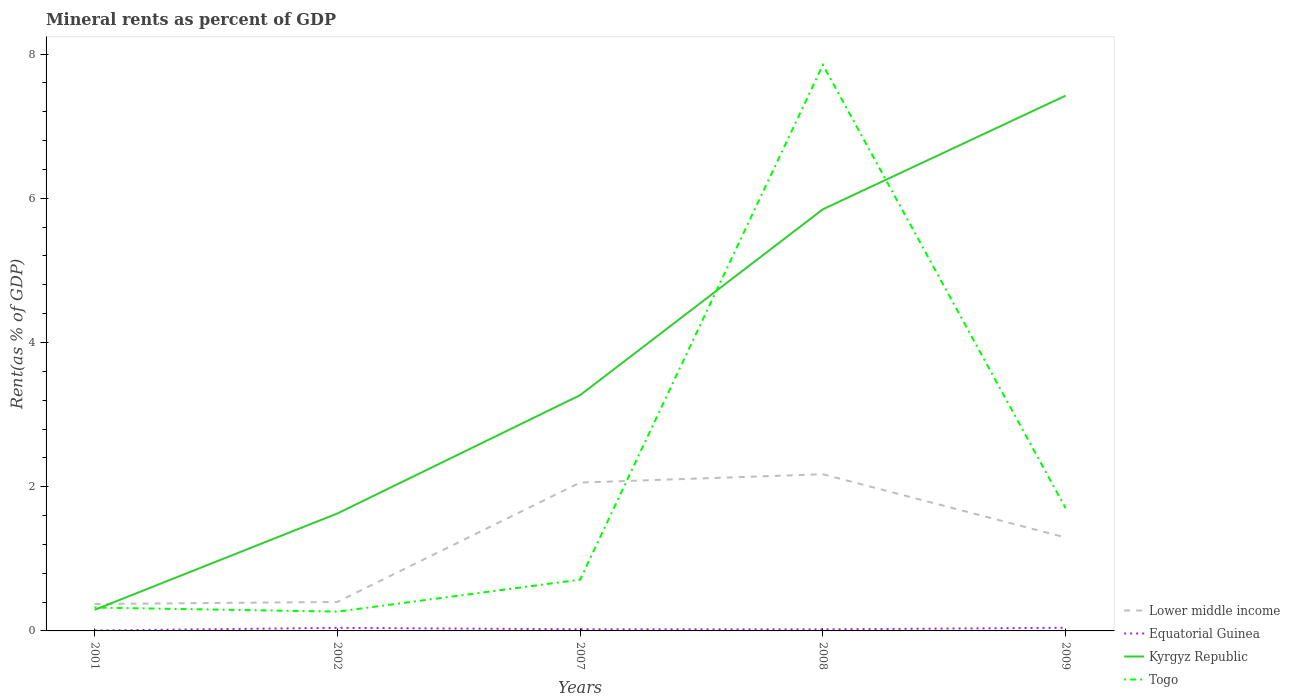Across all years, what is the maximum mineral rent in Togo?
Give a very brief answer. 0.27. What is the total mineral rent in Kyrgyz Republic in the graph?
Provide a short and direct response. -5.56. What is the difference between the highest and the second highest mineral rent in Togo?
Your answer should be very brief. 7.58. How many lines are there?
Your response must be concise. 4. Does the graph contain grids?
Make the answer very short. No. How many legend labels are there?
Your response must be concise. 4. What is the title of the graph?
Your answer should be compact. Mineral rents as percent of GDP. Does "India" appear as one of the legend labels in the graph?
Keep it short and to the point. No. What is the label or title of the X-axis?
Make the answer very short. Years. What is the label or title of the Y-axis?
Your answer should be compact. Rent(as % of GDP). What is the Rent(as % of GDP) of Lower middle income in 2001?
Provide a succinct answer. 0.37. What is the Rent(as % of GDP) in Equatorial Guinea in 2001?
Your answer should be compact. 0.01. What is the Rent(as % of GDP) of Kyrgyz Republic in 2001?
Keep it short and to the point. 0.29. What is the Rent(as % of GDP) of Togo in 2001?
Your answer should be compact. 0.32. What is the Rent(as % of GDP) in Lower middle income in 2002?
Keep it short and to the point. 0.4. What is the Rent(as % of GDP) in Equatorial Guinea in 2002?
Keep it short and to the point. 0.04. What is the Rent(as % of GDP) in Kyrgyz Republic in 2002?
Your response must be concise. 1.63. What is the Rent(as % of GDP) of Togo in 2002?
Your response must be concise. 0.27. What is the Rent(as % of GDP) in Lower middle income in 2007?
Your response must be concise. 2.06. What is the Rent(as % of GDP) in Equatorial Guinea in 2007?
Keep it short and to the point. 0.02. What is the Rent(as % of GDP) of Kyrgyz Republic in 2007?
Keep it short and to the point. 3.27. What is the Rent(as % of GDP) in Togo in 2007?
Provide a short and direct response. 0.71. What is the Rent(as % of GDP) in Lower middle income in 2008?
Offer a very short reply. 2.17. What is the Rent(as % of GDP) of Equatorial Guinea in 2008?
Your answer should be compact. 0.02. What is the Rent(as % of GDP) of Kyrgyz Republic in 2008?
Make the answer very short. 5.85. What is the Rent(as % of GDP) of Togo in 2008?
Offer a terse response. 7.85. What is the Rent(as % of GDP) of Lower middle income in 2009?
Make the answer very short. 1.3. What is the Rent(as % of GDP) in Equatorial Guinea in 2009?
Offer a very short reply. 0.04. What is the Rent(as % of GDP) of Kyrgyz Republic in 2009?
Provide a succinct answer. 7.42. What is the Rent(as % of GDP) in Togo in 2009?
Provide a succinct answer. 1.7. Across all years, what is the maximum Rent(as % of GDP) of Lower middle income?
Ensure brevity in your answer.  2.17. Across all years, what is the maximum Rent(as % of GDP) in Equatorial Guinea?
Give a very brief answer. 0.04. Across all years, what is the maximum Rent(as % of GDP) in Kyrgyz Republic?
Your answer should be compact. 7.42. Across all years, what is the maximum Rent(as % of GDP) of Togo?
Your answer should be compact. 7.85. Across all years, what is the minimum Rent(as % of GDP) of Lower middle income?
Provide a succinct answer. 0.37. Across all years, what is the minimum Rent(as % of GDP) in Equatorial Guinea?
Your answer should be very brief. 0.01. Across all years, what is the minimum Rent(as % of GDP) of Kyrgyz Republic?
Give a very brief answer. 0.29. Across all years, what is the minimum Rent(as % of GDP) of Togo?
Provide a succinct answer. 0.27. What is the total Rent(as % of GDP) in Lower middle income in the graph?
Provide a short and direct response. 6.3. What is the total Rent(as % of GDP) of Equatorial Guinea in the graph?
Provide a short and direct response. 0.14. What is the total Rent(as % of GDP) in Kyrgyz Republic in the graph?
Provide a succinct answer. 18.46. What is the total Rent(as % of GDP) of Togo in the graph?
Your answer should be very brief. 10.85. What is the difference between the Rent(as % of GDP) in Lower middle income in 2001 and that in 2002?
Keep it short and to the point. -0.03. What is the difference between the Rent(as % of GDP) of Equatorial Guinea in 2001 and that in 2002?
Your answer should be very brief. -0.04. What is the difference between the Rent(as % of GDP) in Kyrgyz Republic in 2001 and that in 2002?
Your response must be concise. -1.34. What is the difference between the Rent(as % of GDP) in Togo in 2001 and that in 2002?
Offer a terse response. 0.06. What is the difference between the Rent(as % of GDP) of Lower middle income in 2001 and that in 2007?
Keep it short and to the point. -1.68. What is the difference between the Rent(as % of GDP) of Equatorial Guinea in 2001 and that in 2007?
Offer a very short reply. -0.02. What is the difference between the Rent(as % of GDP) of Kyrgyz Republic in 2001 and that in 2007?
Give a very brief answer. -2.98. What is the difference between the Rent(as % of GDP) of Togo in 2001 and that in 2007?
Ensure brevity in your answer.  -0.39. What is the difference between the Rent(as % of GDP) of Lower middle income in 2001 and that in 2008?
Keep it short and to the point. -1.8. What is the difference between the Rent(as % of GDP) of Equatorial Guinea in 2001 and that in 2008?
Your answer should be compact. -0.02. What is the difference between the Rent(as % of GDP) of Kyrgyz Republic in 2001 and that in 2008?
Offer a very short reply. -5.56. What is the difference between the Rent(as % of GDP) in Togo in 2001 and that in 2008?
Ensure brevity in your answer.  -7.53. What is the difference between the Rent(as % of GDP) of Lower middle income in 2001 and that in 2009?
Provide a succinct answer. -0.92. What is the difference between the Rent(as % of GDP) in Equatorial Guinea in 2001 and that in 2009?
Make the answer very short. -0.04. What is the difference between the Rent(as % of GDP) of Kyrgyz Republic in 2001 and that in 2009?
Your answer should be compact. -7.13. What is the difference between the Rent(as % of GDP) of Togo in 2001 and that in 2009?
Give a very brief answer. -1.38. What is the difference between the Rent(as % of GDP) in Lower middle income in 2002 and that in 2007?
Give a very brief answer. -1.66. What is the difference between the Rent(as % of GDP) of Equatorial Guinea in 2002 and that in 2007?
Give a very brief answer. 0.02. What is the difference between the Rent(as % of GDP) of Kyrgyz Republic in 2002 and that in 2007?
Your answer should be compact. -1.64. What is the difference between the Rent(as % of GDP) in Togo in 2002 and that in 2007?
Offer a very short reply. -0.44. What is the difference between the Rent(as % of GDP) of Lower middle income in 2002 and that in 2008?
Your answer should be compact. -1.77. What is the difference between the Rent(as % of GDP) in Equatorial Guinea in 2002 and that in 2008?
Offer a terse response. 0.02. What is the difference between the Rent(as % of GDP) in Kyrgyz Republic in 2002 and that in 2008?
Your answer should be compact. -4.22. What is the difference between the Rent(as % of GDP) in Togo in 2002 and that in 2008?
Offer a very short reply. -7.58. What is the difference between the Rent(as % of GDP) of Lower middle income in 2002 and that in 2009?
Your answer should be compact. -0.89. What is the difference between the Rent(as % of GDP) of Equatorial Guinea in 2002 and that in 2009?
Make the answer very short. -0. What is the difference between the Rent(as % of GDP) of Kyrgyz Republic in 2002 and that in 2009?
Ensure brevity in your answer.  -5.79. What is the difference between the Rent(as % of GDP) in Togo in 2002 and that in 2009?
Your response must be concise. -1.43. What is the difference between the Rent(as % of GDP) in Lower middle income in 2007 and that in 2008?
Provide a succinct answer. -0.12. What is the difference between the Rent(as % of GDP) in Equatorial Guinea in 2007 and that in 2008?
Your answer should be very brief. 0. What is the difference between the Rent(as % of GDP) of Kyrgyz Republic in 2007 and that in 2008?
Your answer should be very brief. -2.58. What is the difference between the Rent(as % of GDP) in Togo in 2007 and that in 2008?
Give a very brief answer. -7.14. What is the difference between the Rent(as % of GDP) in Lower middle income in 2007 and that in 2009?
Your response must be concise. 0.76. What is the difference between the Rent(as % of GDP) of Equatorial Guinea in 2007 and that in 2009?
Ensure brevity in your answer.  -0.02. What is the difference between the Rent(as % of GDP) of Kyrgyz Republic in 2007 and that in 2009?
Your answer should be compact. -4.15. What is the difference between the Rent(as % of GDP) in Togo in 2007 and that in 2009?
Ensure brevity in your answer.  -0.99. What is the difference between the Rent(as % of GDP) of Lower middle income in 2008 and that in 2009?
Make the answer very short. 0.88. What is the difference between the Rent(as % of GDP) of Equatorial Guinea in 2008 and that in 2009?
Provide a short and direct response. -0.02. What is the difference between the Rent(as % of GDP) in Kyrgyz Republic in 2008 and that in 2009?
Make the answer very short. -1.58. What is the difference between the Rent(as % of GDP) in Togo in 2008 and that in 2009?
Your answer should be very brief. 6.15. What is the difference between the Rent(as % of GDP) in Lower middle income in 2001 and the Rent(as % of GDP) in Equatorial Guinea in 2002?
Ensure brevity in your answer.  0.33. What is the difference between the Rent(as % of GDP) in Lower middle income in 2001 and the Rent(as % of GDP) in Kyrgyz Republic in 2002?
Your answer should be very brief. -1.26. What is the difference between the Rent(as % of GDP) in Lower middle income in 2001 and the Rent(as % of GDP) in Togo in 2002?
Offer a very short reply. 0.11. What is the difference between the Rent(as % of GDP) of Equatorial Guinea in 2001 and the Rent(as % of GDP) of Kyrgyz Republic in 2002?
Your answer should be very brief. -1.62. What is the difference between the Rent(as % of GDP) in Equatorial Guinea in 2001 and the Rent(as % of GDP) in Togo in 2002?
Provide a succinct answer. -0.26. What is the difference between the Rent(as % of GDP) of Kyrgyz Republic in 2001 and the Rent(as % of GDP) of Togo in 2002?
Offer a very short reply. 0.02. What is the difference between the Rent(as % of GDP) of Lower middle income in 2001 and the Rent(as % of GDP) of Equatorial Guinea in 2007?
Ensure brevity in your answer.  0.35. What is the difference between the Rent(as % of GDP) in Lower middle income in 2001 and the Rent(as % of GDP) in Kyrgyz Republic in 2007?
Provide a short and direct response. -2.9. What is the difference between the Rent(as % of GDP) of Lower middle income in 2001 and the Rent(as % of GDP) of Togo in 2007?
Your answer should be very brief. -0.34. What is the difference between the Rent(as % of GDP) in Equatorial Guinea in 2001 and the Rent(as % of GDP) in Kyrgyz Republic in 2007?
Provide a short and direct response. -3.26. What is the difference between the Rent(as % of GDP) of Equatorial Guinea in 2001 and the Rent(as % of GDP) of Togo in 2007?
Provide a succinct answer. -0.7. What is the difference between the Rent(as % of GDP) of Kyrgyz Republic in 2001 and the Rent(as % of GDP) of Togo in 2007?
Your response must be concise. -0.42. What is the difference between the Rent(as % of GDP) in Lower middle income in 2001 and the Rent(as % of GDP) in Equatorial Guinea in 2008?
Your response must be concise. 0.35. What is the difference between the Rent(as % of GDP) of Lower middle income in 2001 and the Rent(as % of GDP) of Kyrgyz Republic in 2008?
Provide a short and direct response. -5.47. What is the difference between the Rent(as % of GDP) of Lower middle income in 2001 and the Rent(as % of GDP) of Togo in 2008?
Your answer should be very brief. -7.48. What is the difference between the Rent(as % of GDP) of Equatorial Guinea in 2001 and the Rent(as % of GDP) of Kyrgyz Republic in 2008?
Keep it short and to the point. -5.84. What is the difference between the Rent(as % of GDP) of Equatorial Guinea in 2001 and the Rent(as % of GDP) of Togo in 2008?
Give a very brief answer. -7.84. What is the difference between the Rent(as % of GDP) of Kyrgyz Republic in 2001 and the Rent(as % of GDP) of Togo in 2008?
Keep it short and to the point. -7.56. What is the difference between the Rent(as % of GDP) of Lower middle income in 2001 and the Rent(as % of GDP) of Equatorial Guinea in 2009?
Make the answer very short. 0.33. What is the difference between the Rent(as % of GDP) of Lower middle income in 2001 and the Rent(as % of GDP) of Kyrgyz Republic in 2009?
Your response must be concise. -7.05. What is the difference between the Rent(as % of GDP) in Lower middle income in 2001 and the Rent(as % of GDP) in Togo in 2009?
Keep it short and to the point. -1.33. What is the difference between the Rent(as % of GDP) of Equatorial Guinea in 2001 and the Rent(as % of GDP) of Kyrgyz Republic in 2009?
Give a very brief answer. -7.42. What is the difference between the Rent(as % of GDP) of Equatorial Guinea in 2001 and the Rent(as % of GDP) of Togo in 2009?
Your answer should be compact. -1.7. What is the difference between the Rent(as % of GDP) of Kyrgyz Republic in 2001 and the Rent(as % of GDP) of Togo in 2009?
Provide a succinct answer. -1.41. What is the difference between the Rent(as % of GDP) of Lower middle income in 2002 and the Rent(as % of GDP) of Equatorial Guinea in 2007?
Your response must be concise. 0.38. What is the difference between the Rent(as % of GDP) in Lower middle income in 2002 and the Rent(as % of GDP) in Kyrgyz Republic in 2007?
Offer a terse response. -2.87. What is the difference between the Rent(as % of GDP) of Lower middle income in 2002 and the Rent(as % of GDP) of Togo in 2007?
Give a very brief answer. -0.31. What is the difference between the Rent(as % of GDP) of Equatorial Guinea in 2002 and the Rent(as % of GDP) of Kyrgyz Republic in 2007?
Provide a succinct answer. -3.23. What is the difference between the Rent(as % of GDP) of Equatorial Guinea in 2002 and the Rent(as % of GDP) of Togo in 2007?
Your answer should be very brief. -0.67. What is the difference between the Rent(as % of GDP) of Kyrgyz Republic in 2002 and the Rent(as % of GDP) of Togo in 2007?
Ensure brevity in your answer.  0.92. What is the difference between the Rent(as % of GDP) in Lower middle income in 2002 and the Rent(as % of GDP) in Equatorial Guinea in 2008?
Offer a very short reply. 0.38. What is the difference between the Rent(as % of GDP) in Lower middle income in 2002 and the Rent(as % of GDP) in Kyrgyz Republic in 2008?
Your answer should be very brief. -5.45. What is the difference between the Rent(as % of GDP) in Lower middle income in 2002 and the Rent(as % of GDP) in Togo in 2008?
Offer a very short reply. -7.45. What is the difference between the Rent(as % of GDP) in Equatorial Guinea in 2002 and the Rent(as % of GDP) in Kyrgyz Republic in 2008?
Offer a very short reply. -5.8. What is the difference between the Rent(as % of GDP) in Equatorial Guinea in 2002 and the Rent(as % of GDP) in Togo in 2008?
Provide a succinct answer. -7.81. What is the difference between the Rent(as % of GDP) in Kyrgyz Republic in 2002 and the Rent(as % of GDP) in Togo in 2008?
Ensure brevity in your answer.  -6.22. What is the difference between the Rent(as % of GDP) of Lower middle income in 2002 and the Rent(as % of GDP) of Equatorial Guinea in 2009?
Your answer should be compact. 0.36. What is the difference between the Rent(as % of GDP) of Lower middle income in 2002 and the Rent(as % of GDP) of Kyrgyz Republic in 2009?
Your answer should be very brief. -7.02. What is the difference between the Rent(as % of GDP) of Lower middle income in 2002 and the Rent(as % of GDP) of Togo in 2009?
Make the answer very short. -1.3. What is the difference between the Rent(as % of GDP) of Equatorial Guinea in 2002 and the Rent(as % of GDP) of Kyrgyz Republic in 2009?
Provide a succinct answer. -7.38. What is the difference between the Rent(as % of GDP) of Equatorial Guinea in 2002 and the Rent(as % of GDP) of Togo in 2009?
Keep it short and to the point. -1.66. What is the difference between the Rent(as % of GDP) in Kyrgyz Republic in 2002 and the Rent(as % of GDP) in Togo in 2009?
Offer a terse response. -0.07. What is the difference between the Rent(as % of GDP) in Lower middle income in 2007 and the Rent(as % of GDP) in Equatorial Guinea in 2008?
Offer a very short reply. 2.04. What is the difference between the Rent(as % of GDP) of Lower middle income in 2007 and the Rent(as % of GDP) of Kyrgyz Republic in 2008?
Provide a short and direct response. -3.79. What is the difference between the Rent(as % of GDP) in Lower middle income in 2007 and the Rent(as % of GDP) in Togo in 2008?
Give a very brief answer. -5.79. What is the difference between the Rent(as % of GDP) in Equatorial Guinea in 2007 and the Rent(as % of GDP) in Kyrgyz Republic in 2008?
Give a very brief answer. -5.82. What is the difference between the Rent(as % of GDP) of Equatorial Guinea in 2007 and the Rent(as % of GDP) of Togo in 2008?
Offer a terse response. -7.83. What is the difference between the Rent(as % of GDP) in Kyrgyz Republic in 2007 and the Rent(as % of GDP) in Togo in 2008?
Your answer should be very brief. -4.58. What is the difference between the Rent(as % of GDP) of Lower middle income in 2007 and the Rent(as % of GDP) of Equatorial Guinea in 2009?
Make the answer very short. 2.01. What is the difference between the Rent(as % of GDP) of Lower middle income in 2007 and the Rent(as % of GDP) of Kyrgyz Republic in 2009?
Offer a terse response. -5.37. What is the difference between the Rent(as % of GDP) of Lower middle income in 2007 and the Rent(as % of GDP) of Togo in 2009?
Provide a short and direct response. 0.36. What is the difference between the Rent(as % of GDP) in Equatorial Guinea in 2007 and the Rent(as % of GDP) in Kyrgyz Republic in 2009?
Your response must be concise. -7.4. What is the difference between the Rent(as % of GDP) of Equatorial Guinea in 2007 and the Rent(as % of GDP) of Togo in 2009?
Your answer should be compact. -1.68. What is the difference between the Rent(as % of GDP) of Kyrgyz Republic in 2007 and the Rent(as % of GDP) of Togo in 2009?
Offer a very short reply. 1.57. What is the difference between the Rent(as % of GDP) in Lower middle income in 2008 and the Rent(as % of GDP) in Equatorial Guinea in 2009?
Your answer should be compact. 2.13. What is the difference between the Rent(as % of GDP) in Lower middle income in 2008 and the Rent(as % of GDP) in Kyrgyz Republic in 2009?
Your answer should be very brief. -5.25. What is the difference between the Rent(as % of GDP) of Lower middle income in 2008 and the Rent(as % of GDP) of Togo in 2009?
Your response must be concise. 0.47. What is the difference between the Rent(as % of GDP) of Equatorial Guinea in 2008 and the Rent(as % of GDP) of Kyrgyz Republic in 2009?
Your answer should be very brief. -7.4. What is the difference between the Rent(as % of GDP) of Equatorial Guinea in 2008 and the Rent(as % of GDP) of Togo in 2009?
Offer a very short reply. -1.68. What is the difference between the Rent(as % of GDP) of Kyrgyz Republic in 2008 and the Rent(as % of GDP) of Togo in 2009?
Give a very brief answer. 4.15. What is the average Rent(as % of GDP) of Lower middle income per year?
Your answer should be very brief. 1.26. What is the average Rent(as % of GDP) of Equatorial Guinea per year?
Your response must be concise. 0.03. What is the average Rent(as % of GDP) of Kyrgyz Republic per year?
Make the answer very short. 3.69. What is the average Rent(as % of GDP) of Togo per year?
Provide a short and direct response. 2.17. In the year 2001, what is the difference between the Rent(as % of GDP) of Lower middle income and Rent(as % of GDP) of Equatorial Guinea?
Your response must be concise. 0.37. In the year 2001, what is the difference between the Rent(as % of GDP) in Lower middle income and Rent(as % of GDP) in Kyrgyz Republic?
Ensure brevity in your answer.  0.08. In the year 2001, what is the difference between the Rent(as % of GDP) of Lower middle income and Rent(as % of GDP) of Togo?
Your response must be concise. 0.05. In the year 2001, what is the difference between the Rent(as % of GDP) of Equatorial Guinea and Rent(as % of GDP) of Kyrgyz Republic?
Your answer should be compact. -0.29. In the year 2001, what is the difference between the Rent(as % of GDP) of Equatorial Guinea and Rent(as % of GDP) of Togo?
Offer a terse response. -0.32. In the year 2001, what is the difference between the Rent(as % of GDP) of Kyrgyz Republic and Rent(as % of GDP) of Togo?
Give a very brief answer. -0.03. In the year 2002, what is the difference between the Rent(as % of GDP) in Lower middle income and Rent(as % of GDP) in Equatorial Guinea?
Make the answer very short. 0.36. In the year 2002, what is the difference between the Rent(as % of GDP) of Lower middle income and Rent(as % of GDP) of Kyrgyz Republic?
Your answer should be very brief. -1.23. In the year 2002, what is the difference between the Rent(as % of GDP) in Lower middle income and Rent(as % of GDP) in Togo?
Give a very brief answer. 0.13. In the year 2002, what is the difference between the Rent(as % of GDP) in Equatorial Guinea and Rent(as % of GDP) in Kyrgyz Republic?
Your answer should be very brief. -1.59. In the year 2002, what is the difference between the Rent(as % of GDP) in Equatorial Guinea and Rent(as % of GDP) in Togo?
Your answer should be compact. -0.23. In the year 2002, what is the difference between the Rent(as % of GDP) in Kyrgyz Republic and Rent(as % of GDP) in Togo?
Make the answer very short. 1.36. In the year 2007, what is the difference between the Rent(as % of GDP) in Lower middle income and Rent(as % of GDP) in Equatorial Guinea?
Make the answer very short. 2.03. In the year 2007, what is the difference between the Rent(as % of GDP) of Lower middle income and Rent(as % of GDP) of Kyrgyz Republic?
Provide a short and direct response. -1.21. In the year 2007, what is the difference between the Rent(as % of GDP) in Lower middle income and Rent(as % of GDP) in Togo?
Make the answer very short. 1.35. In the year 2007, what is the difference between the Rent(as % of GDP) in Equatorial Guinea and Rent(as % of GDP) in Kyrgyz Republic?
Provide a succinct answer. -3.25. In the year 2007, what is the difference between the Rent(as % of GDP) in Equatorial Guinea and Rent(as % of GDP) in Togo?
Provide a succinct answer. -0.69. In the year 2007, what is the difference between the Rent(as % of GDP) in Kyrgyz Republic and Rent(as % of GDP) in Togo?
Make the answer very short. 2.56. In the year 2008, what is the difference between the Rent(as % of GDP) in Lower middle income and Rent(as % of GDP) in Equatorial Guinea?
Offer a very short reply. 2.15. In the year 2008, what is the difference between the Rent(as % of GDP) in Lower middle income and Rent(as % of GDP) in Kyrgyz Republic?
Provide a succinct answer. -3.67. In the year 2008, what is the difference between the Rent(as % of GDP) in Lower middle income and Rent(as % of GDP) in Togo?
Give a very brief answer. -5.68. In the year 2008, what is the difference between the Rent(as % of GDP) in Equatorial Guinea and Rent(as % of GDP) in Kyrgyz Republic?
Your response must be concise. -5.83. In the year 2008, what is the difference between the Rent(as % of GDP) in Equatorial Guinea and Rent(as % of GDP) in Togo?
Ensure brevity in your answer.  -7.83. In the year 2008, what is the difference between the Rent(as % of GDP) of Kyrgyz Republic and Rent(as % of GDP) of Togo?
Provide a short and direct response. -2. In the year 2009, what is the difference between the Rent(as % of GDP) in Lower middle income and Rent(as % of GDP) in Equatorial Guinea?
Your response must be concise. 1.25. In the year 2009, what is the difference between the Rent(as % of GDP) in Lower middle income and Rent(as % of GDP) in Kyrgyz Republic?
Offer a terse response. -6.13. In the year 2009, what is the difference between the Rent(as % of GDP) of Lower middle income and Rent(as % of GDP) of Togo?
Offer a very short reply. -0.41. In the year 2009, what is the difference between the Rent(as % of GDP) in Equatorial Guinea and Rent(as % of GDP) in Kyrgyz Republic?
Provide a succinct answer. -7.38. In the year 2009, what is the difference between the Rent(as % of GDP) of Equatorial Guinea and Rent(as % of GDP) of Togo?
Your response must be concise. -1.66. In the year 2009, what is the difference between the Rent(as % of GDP) of Kyrgyz Republic and Rent(as % of GDP) of Togo?
Offer a terse response. 5.72. What is the ratio of the Rent(as % of GDP) in Lower middle income in 2001 to that in 2002?
Your answer should be very brief. 0.93. What is the ratio of the Rent(as % of GDP) of Equatorial Guinea in 2001 to that in 2002?
Offer a terse response. 0.15. What is the ratio of the Rent(as % of GDP) in Kyrgyz Republic in 2001 to that in 2002?
Offer a terse response. 0.18. What is the ratio of the Rent(as % of GDP) of Togo in 2001 to that in 2002?
Provide a short and direct response. 1.21. What is the ratio of the Rent(as % of GDP) in Lower middle income in 2001 to that in 2007?
Offer a terse response. 0.18. What is the ratio of the Rent(as % of GDP) in Equatorial Guinea in 2001 to that in 2007?
Your answer should be very brief. 0.27. What is the ratio of the Rent(as % of GDP) of Kyrgyz Republic in 2001 to that in 2007?
Offer a terse response. 0.09. What is the ratio of the Rent(as % of GDP) in Togo in 2001 to that in 2007?
Your answer should be compact. 0.46. What is the ratio of the Rent(as % of GDP) of Lower middle income in 2001 to that in 2008?
Ensure brevity in your answer.  0.17. What is the ratio of the Rent(as % of GDP) of Equatorial Guinea in 2001 to that in 2008?
Offer a terse response. 0.3. What is the ratio of the Rent(as % of GDP) of Kyrgyz Republic in 2001 to that in 2008?
Your answer should be very brief. 0.05. What is the ratio of the Rent(as % of GDP) of Togo in 2001 to that in 2008?
Your answer should be compact. 0.04. What is the ratio of the Rent(as % of GDP) in Lower middle income in 2001 to that in 2009?
Ensure brevity in your answer.  0.29. What is the ratio of the Rent(as % of GDP) of Equatorial Guinea in 2001 to that in 2009?
Give a very brief answer. 0.14. What is the ratio of the Rent(as % of GDP) in Kyrgyz Republic in 2001 to that in 2009?
Keep it short and to the point. 0.04. What is the ratio of the Rent(as % of GDP) of Togo in 2001 to that in 2009?
Ensure brevity in your answer.  0.19. What is the ratio of the Rent(as % of GDP) of Lower middle income in 2002 to that in 2007?
Provide a short and direct response. 0.2. What is the ratio of the Rent(as % of GDP) of Equatorial Guinea in 2002 to that in 2007?
Keep it short and to the point. 1.84. What is the ratio of the Rent(as % of GDP) of Kyrgyz Republic in 2002 to that in 2007?
Offer a very short reply. 0.5. What is the ratio of the Rent(as % of GDP) of Togo in 2002 to that in 2007?
Give a very brief answer. 0.38. What is the ratio of the Rent(as % of GDP) in Lower middle income in 2002 to that in 2008?
Make the answer very short. 0.18. What is the ratio of the Rent(as % of GDP) of Equatorial Guinea in 2002 to that in 2008?
Provide a short and direct response. 1.98. What is the ratio of the Rent(as % of GDP) of Kyrgyz Republic in 2002 to that in 2008?
Provide a succinct answer. 0.28. What is the ratio of the Rent(as % of GDP) of Togo in 2002 to that in 2008?
Your answer should be very brief. 0.03. What is the ratio of the Rent(as % of GDP) of Lower middle income in 2002 to that in 2009?
Your answer should be compact. 0.31. What is the ratio of the Rent(as % of GDP) in Equatorial Guinea in 2002 to that in 2009?
Provide a short and direct response. 0.97. What is the ratio of the Rent(as % of GDP) of Kyrgyz Republic in 2002 to that in 2009?
Your answer should be compact. 0.22. What is the ratio of the Rent(as % of GDP) in Togo in 2002 to that in 2009?
Give a very brief answer. 0.16. What is the ratio of the Rent(as % of GDP) in Lower middle income in 2007 to that in 2008?
Offer a terse response. 0.95. What is the ratio of the Rent(as % of GDP) of Equatorial Guinea in 2007 to that in 2008?
Provide a short and direct response. 1.08. What is the ratio of the Rent(as % of GDP) in Kyrgyz Republic in 2007 to that in 2008?
Your response must be concise. 0.56. What is the ratio of the Rent(as % of GDP) of Togo in 2007 to that in 2008?
Provide a succinct answer. 0.09. What is the ratio of the Rent(as % of GDP) of Lower middle income in 2007 to that in 2009?
Your response must be concise. 1.59. What is the ratio of the Rent(as % of GDP) in Equatorial Guinea in 2007 to that in 2009?
Your answer should be compact. 0.53. What is the ratio of the Rent(as % of GDP) in Kyrgyz Republic in 2007 to that in 2009?
Your response must be concise. 0.44. What is the ratio of the Rent(as % of GDP) in Togo in 2007 to that in 2009?
Make the answer very short. 0.42. What is the ratio of the Rent(as % of GDP) in Lower middle income in 2008 to that in 2009?
Your answer should be compact. 1.68. What is the ratio of the Rent(as % of GDP) of Equatorial Guinea in 2008 to that in 2009?
Provide a short and direct response. 0.49. What is the ratio of the Rent(as % of GDP) of Kyrgyz Republic in 2008 to that in 2009?
Your answer should be compact. 0.79. What is the ratio of the Rent(as % of GDP) of Togo in 2008 to that in 2009?
Your response must be concise. 4.61. What is the difference between the highest and the second highest Rent(as % of GDP) of Lower middle income?
Make the answer very short. 0.12. What is the difference between the highest and the second highest Rent(as % of GDP) in Equatorial Guinea?
Offer a very short reply. 0. What is the difference between the highest and the second highest Rent(as % of GDP) of Kyrgyz Republic?
Your response must be concise. 1.58. What is the difference between the highest and the second highest Rent(as % of GDP) of Togo?
Your answer should be very brief. 6.15. What is the difference between the highest and the lowest Rent(as % of GDP) of Lower middle income?
Your answer should be compact. 1.8. What is the difference between the highest and the lowest Rent(as % of GDP) in Equatorial Guinea?
Your answer should be very brief. 0.04. What is the difference between the highest and the lowest Rent(as % of GDP) in Kyrgyz Republic?
Keep it short and to the point. 7.13. What is the difference between the highest and the lowest Rent(as % of GDP) in Togo?
Provide a short and direct response. 7.58. 